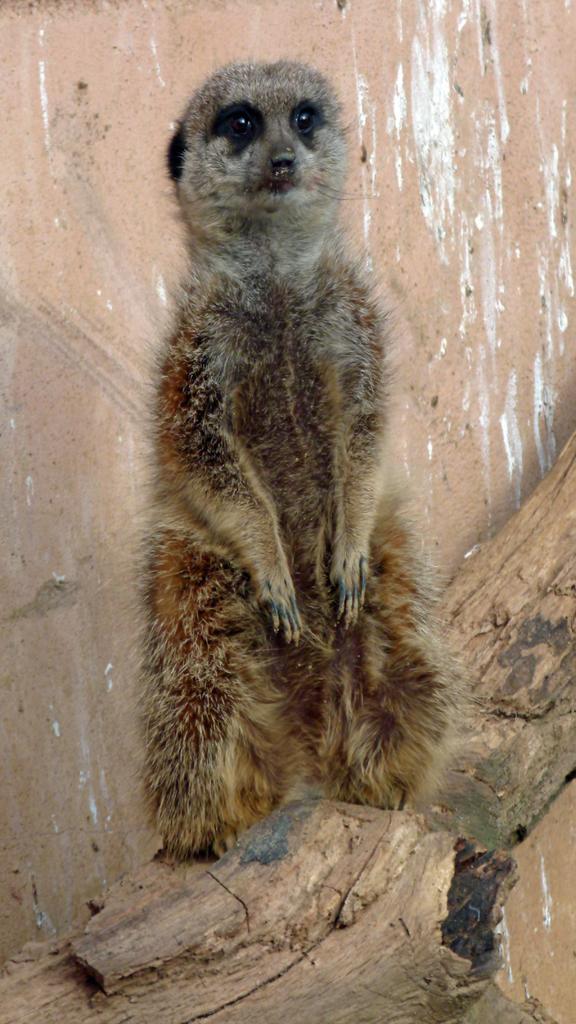Please provide a concise description of this image. This picture contains an animal which is in brown color is standing on the wood. Behind that, we see a wall in pink color. This picture is clicked in the zoo. 